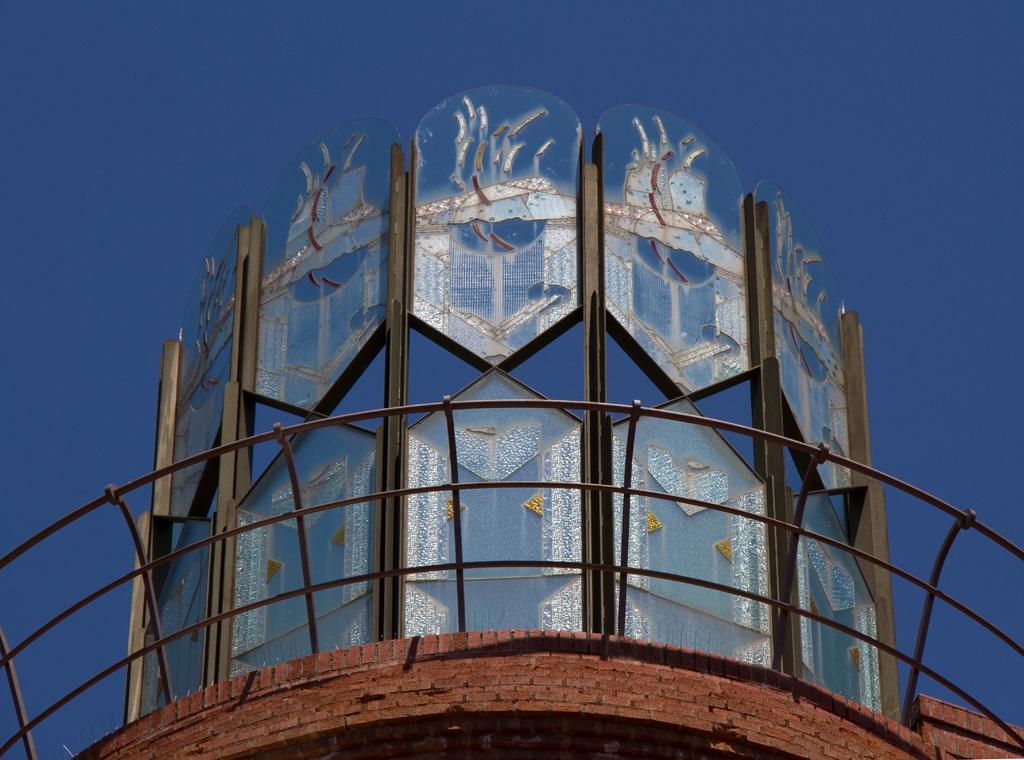Could you give a brief overview of what you see in this image? In this picture, it looks like an architectural building and iron grilles. Behind the architectural building, there is the sky. 